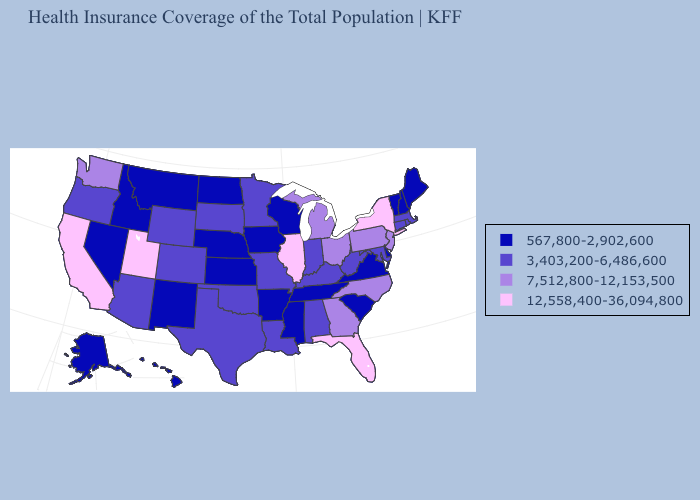Among the states that border Texas , which have the highest value?
Short answer required. Louisiana, Oklahoma. Among the states that border Kansas , does Colorado have the highest value?
Quick response, please. Yes. Does North Dakota have the highest value in the USA?
Be succinct. No. Which states have the lowest value in the Northeast?
Quick response, please. Maine, New Hampshire, Vermont. What is the lowest value in states that border New York?
Quick response, please. 567,800-2,902,600. Name the states that have a value in the range 7,512,800-12,153,500?
Concise answer only. Georgia, Michigan, New Jersey, North Carolina, Ohio, Pennsylvania, Washington. What is the highest value in the South ?
Be succinct. 12,558,400-36,094,800. Does New York have the highest value in the USA?
Write a very short answer. Yes. What is the value of Wisconsin?
Quick response, please. 567,800-2,902,600. Which states hav the highest value in the MidWest?
Concise answer only. Illinois. Name the states that have a value in the range 567,800-2,902,600?
Short answer required. Alaska, Arkansas, Delaware, Hawaii, Idaho, Iowa, Kansas, Maine, Mississippi, Montana, Nebraska, Nevada, New Hampshire, New Mexico, North Dakota, South Carolina, Tennessee, Vermont, Virginia, Wisconsin. Name the states that have a value in the range 12,558,400-36,094,800?
Short answer required. California, Florida, Illinois, New York, Utah. Name the states that have a value in the range 3,403,200-6,486,600?
Quick response, please. Alabama, Arizona, Colorado, Connecticut, Indiana, Kentucky, Louisiana, Maryland, Massachusetts, Minnesota, Missouri, Oklahoma, Oregon, Rhode Island, South Dakota, Texas, West Virginia, Wyoming. What is the value of Arkansas?
Write a very short answer. 567,800-2,902,600. 